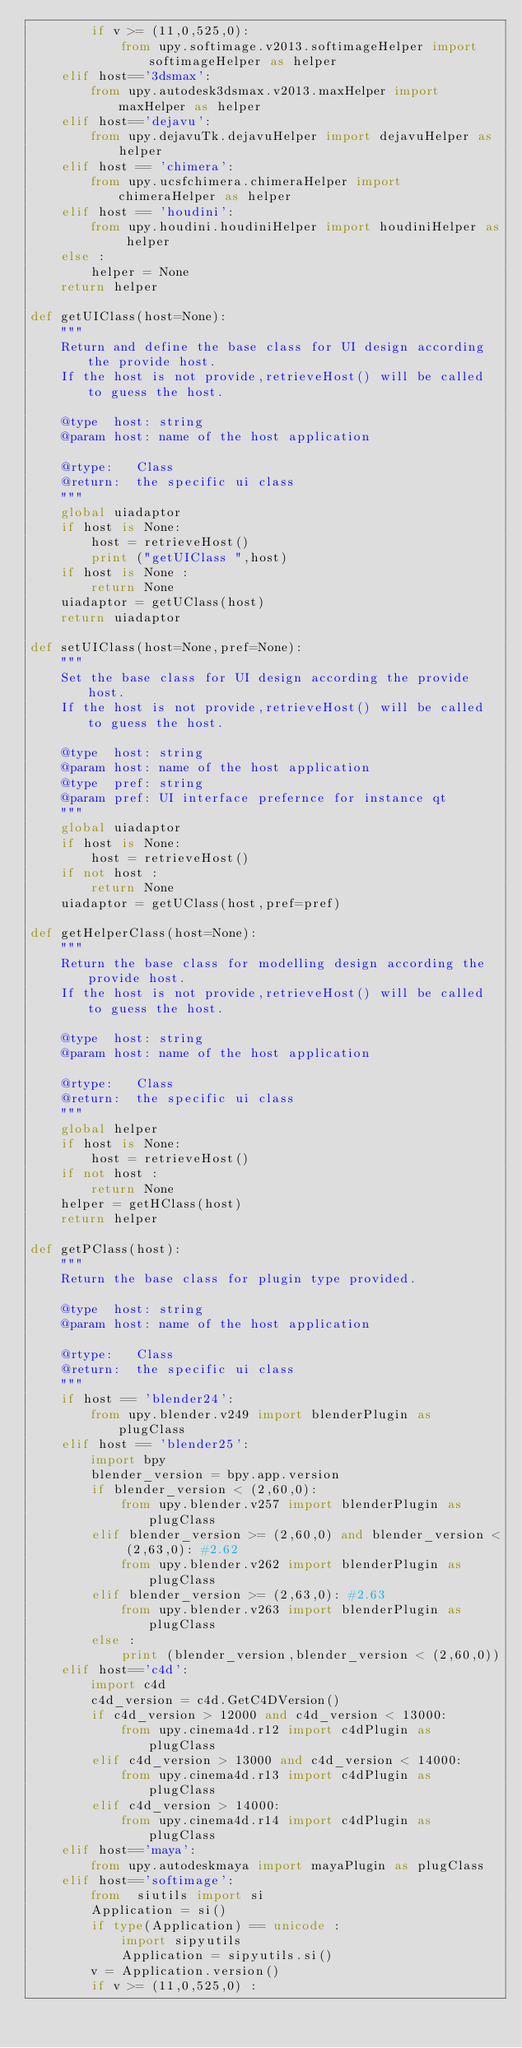<code> <loc_0><loc_0><loc_500><loc_500><_Python_>        if v >= (11,0,525,0):
            from upy.softimage.v2013.softimageHelper import softimageHelper as helper
    elif host=='3dsmax':
        from upy.autodesk3dsmax.v2013.maxHelper import maxHelper as helper
    elif host=='dejavu':
        from upy.dejavuTk.dejavuHelper import dejavuHelper as helper
    elif host == 'chimera':
        from upy.ucsfchimera.chimeraHelper import chimeraHelper as helper
    elif host == 'houdini': 
        from upy.houdini.houdiniHelper import houdiniHelper as helper
    else :
        helper = None
    return helper    

def getUIClass(host=None):
    """
    Return and define the base class for UI design according the provide host.
    If the host is not provide,retrieveHost() will be called to guess the host.
    
    @type  host: string
    @param host: name of the host application
    
    @rtype:   Class
    @return:  the specific ui class
    """ 
    global uiadaptor   
    if host is None:
        host = retrieveHost()
        print ("getUIClass ",host)
    if host is None :
        return None
    uiadaptor = getUClass(host)
    return uiadaptor

def setUIClass(host=None,pref=None):
    """
    Set the base class for UI design according the provide host.
    If the host is not provide,retrieveHost() will be called to guess the host.
    
    @type  host: string
    @param host: name of the host application
    @type  pref: string
    @param pref: UI interface prefernce for instance qt    
    """ 
    global uiadaptor  
    if host is None:
        host = retrieveHost()
    if not host :
        return None
    uiadaptor = getUClass(host,pref=pref)

def getHelperClass(host=None):
    """
    Return the base class for modelling design according the provide host.
    If the host is not provide,retrieveHost() will be called to guess the host.
    
    @type  host: string
    @param host: name of the host application
    
    @rtype:   Class
    @return:  the specific ui class
    """ 
    global helper
    if host is None:
        host = retrieveHost()
    if not host :
        return None
    helper = getHClass(host)
    return helper

def getPClass(host):
    """
    Return the base class for plugin type provided.
        
    @type  host: string
    @param host: name of the host application
    
    @rtype:   Class
    @return:  the specific ui class
    """     
    if host == 'blender24':
        from upy.blender.v249 import blenderPlugin as plugClass
    elif host == 'blender25':
        import bpy
        blender_version = bpy.app.version
        if blender_version < (2,60,0):
            from upy.blender.v257 import blenderPlugin as plugClass
        elif blender_version >= (2,60,0) and blender_version < (2,63,0): #2.62
            from upy.blender.v262 import blenderPlugin as plugClass
        elif blender_version >= (2,63,0): #2.63
            from upy.blender.v263 import blenderPlugin as plugClass
        else :
            print (blender_version,blender_version < (2,60,0))
    elif host=='c4d':
        import c4d
        c4d_version = c4d.GetC4DVersion()
        if c4d_version > 12000 and c4d_version < 13000:
            from upy.cinema4d.r12 import c4dPlugin as plugClass
        elif c4d_version > 13000 and c4d_version < 14000:
            from upy.cinema4d.r13 import c4dPlugin as plugClass
        elif c4d_version > 14000:
            from upy.cinema4d.r14 import c4dPlugin as plugClass
    elif host=='maya':
        from upy.autodeskmaya import mayaPlugin as plugClass
    elif host=='softimage':
        from  siutils import si
        Application = si()        
        if type(Application) == unicode :
            import sipyutils
            Application = sipyutils.si()
        v = Application.version()
        if v >= (11,0,525,0) :</code> 